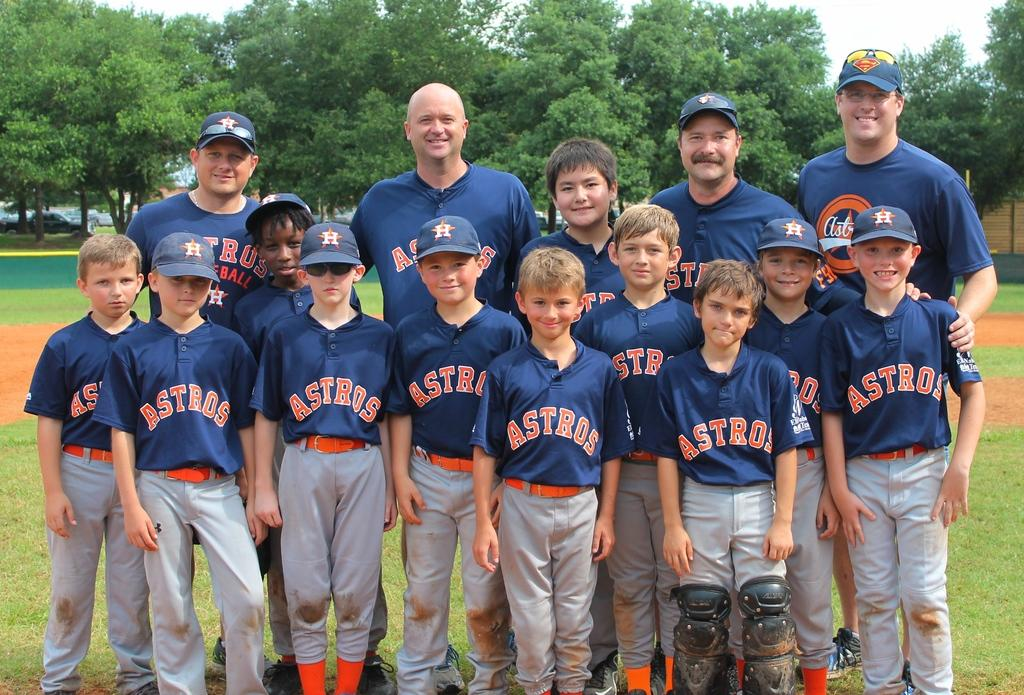<image>
Describe the image concisely. a group of baseball players that have astros on their jersey 